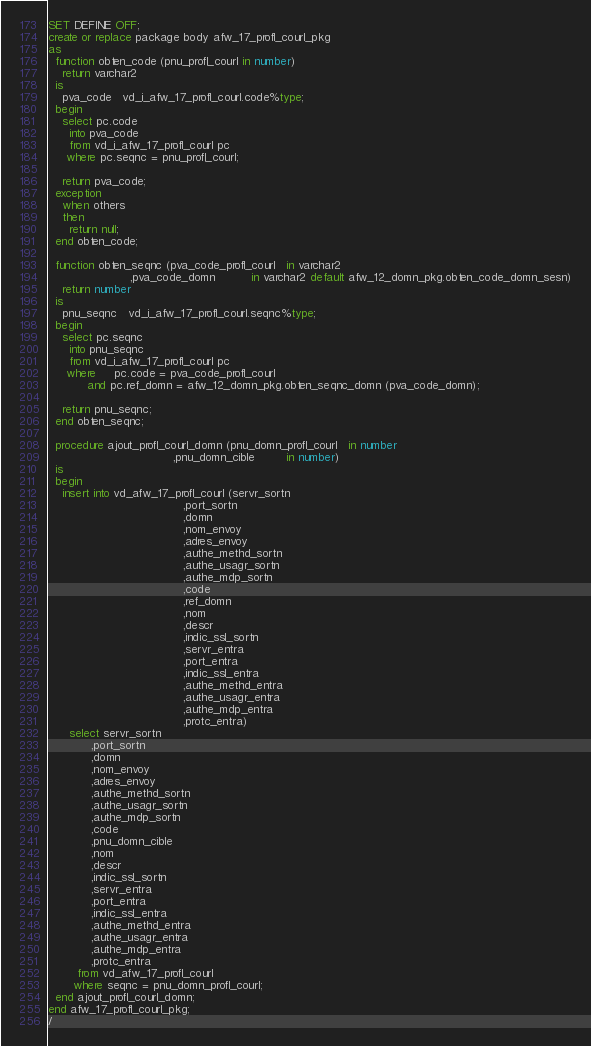Convert code to text. <code><loc_0><loc_0><loc_500><loc_500><_SQL_>SET DEFINE OFF;
create or replace package body afw_17_profl_courl_pkg
as
  function obten_code (pnu_profl_courl in number)
    return varchar2
  is
    pva_code   vd_i_afw_17_profl_courl.code%type;
  begin
    select pc.code
      into pva_code
      from vd_i_afw_17_profl_courl pc
     where pc.seqnc = pnu_profl_courl;

    return pva_code;
  exception
    when others
    then
      return null;
  end obten_code;

  function obten_seqnc (pva_code_profl_courl   in varchar2
                       ,pva_code_domn          in varchar2 default afw_12_domn_pkg.obten_code_domn_sesn)
    return number
  is
    pnu_seqnc   vd_i_afw_17_profl_courl.seqnc%type;
  begin
    select pc.seqnc
      into pnu_seqnc
      from vd_i_afw_17_profl_courl pc
     where     pc.code = pva_code_profl_courl
           and pc.ref_domn = afw_12_domn_pkg.obten_seqnc_domn (pva_code_domn);

    return pnu_seqnc;
  end obten_seqnc;

  procedure ajout_profl_courl_domn (pnu_domn_profl_courl   in number
                                   ,pnu_domn_cible         in number)
  is
  begin
    insert into vd_afw_17_profl_courl (servr_sortn
                                      ,port_sortn
                                      ,domn
                                      ,nom_envoy
                                      ,adres_envoy
                                      ,authe_methd_sortn
                                      ,authe_usagr_sortn
                                      ,authe_mdp_sortn
                                      ,code
                                      ,ref_domn
                                      ,nom
                                      ,descr
                                      ,indic_ssl_sortn
                                      ,servr_entra
                                      ,port_entra
                                      ,indic_ssl_entra
                                      ,authe_methd_entra
                                      ,authe_usagr_entra
                                      ,authe_mdp_entra
                                      ,protc_entra)
      select servr_sortn
            ,port_sortn
            ,domn
            ,nom_envoy
            ,adres_envoy
            ,authe_methd_sortn
            ,authe_usagr_sortn
            ,authe_mdp_sortn
            ,code
            ,pnu_domn_cible
            ,nom
            ,descr
            ,indic_ssl_sortn
            ,servr_entra
            ,port_entra
            ,indic_ssl_entra
            ,authe_methd_entra
            ,authe_usagr_entra
            ,authe_mdp_entra
            ,protc_entra
        from vd_afw_17_profl_courl
       where seqnc = pnu_domn_profl_courl;
  end ajout_profl_courl_domn;
end afw_17_profl_courl_pkg;
/
</code> 